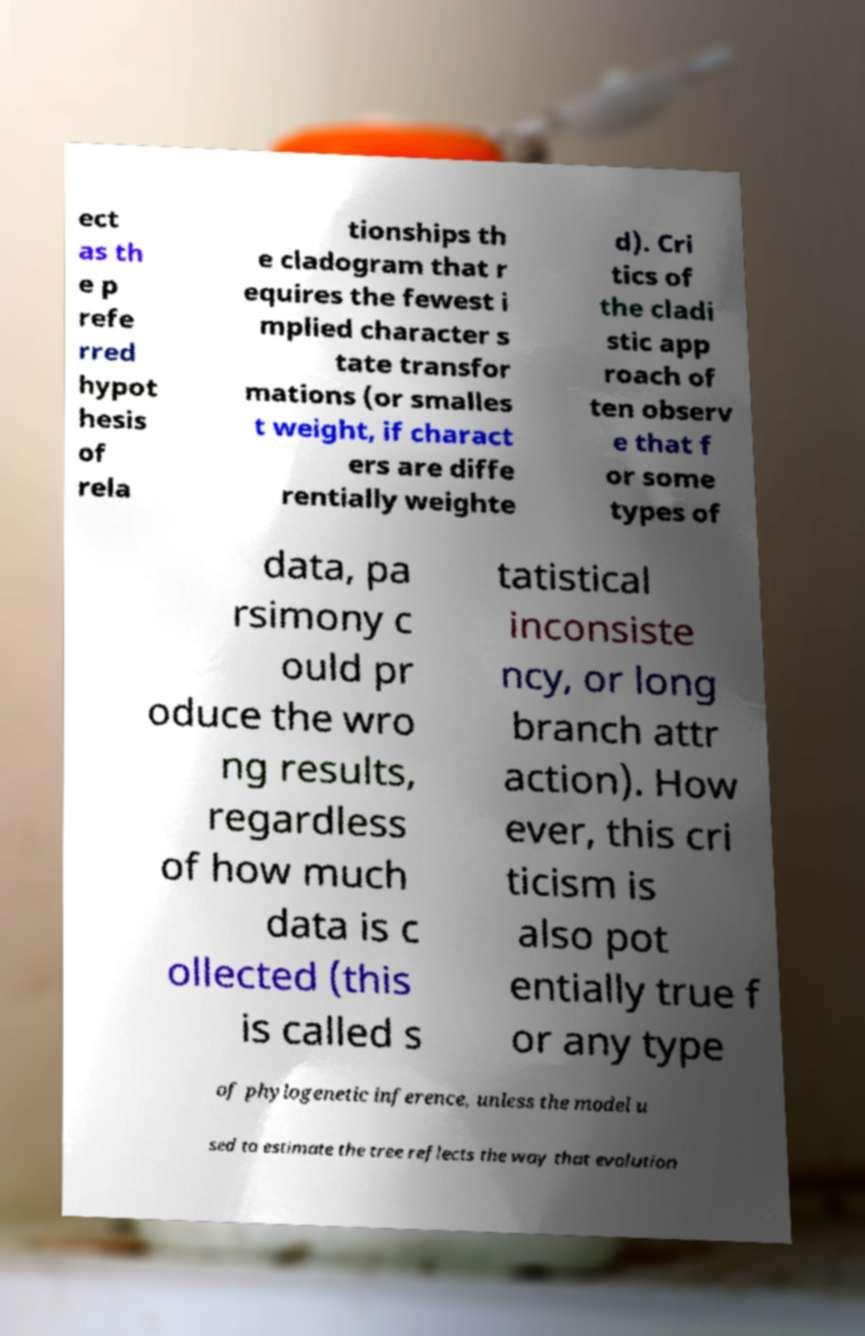Please read and relay the text visible in this image. What does it say? ect as th e p refe rred hypot hesis of rela tionships th e cladogram that r equires the fewest i mplied character s tate transfor mations (or smalles t weight, if charact ers are diffe rentially weighte d). Cri tics of the cladi stic app roach of ten observ e that f or some types of data, pa rsimony c ould pr oduce the wro ng results, regardless of how much data is c ollected (this is called s tatistical inconsiste ncy, or long branch attr action). How ever, this cri ticism is also pot entially true f or any type of phylogenetic inference, unless the model u sed to estimate the tree reflects the way that evolution 